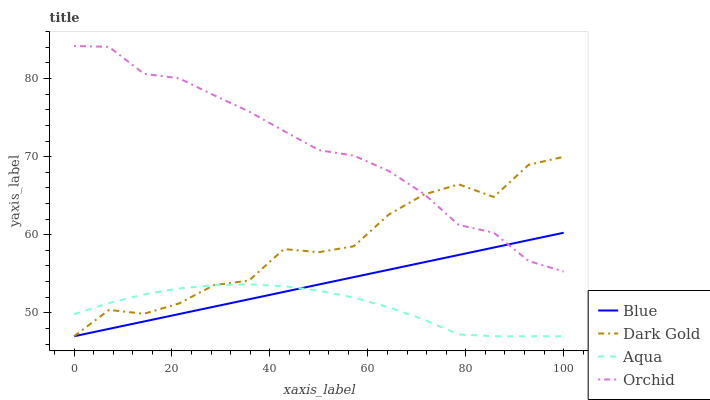Does Aqua have the minimum area under the curve?
Answer yes or no. Yes. Does Orchid have the maximum area under the curve?
Answer yes or no. Yes. Does Orchid have the minimum area under the curve?
Answer yes or no. No. Does Aqua have the maximum area under the curve?
Answer yes or no. No. Is Blue the smoothest?
Answer yes or no. Yes. Is Dark Gold the roughest?
Answer yes or no. Yes. Is Orchid the smoothest?
Answer yes or no. No. Is Orchid the roughest?
Answer yes or no. No. Does Blue have the lowest value?
Answer yes or no. Yes. Does Orchid have the lowest value?
Answer yes or no. No. Does Orchid have the highest value?
Answer yes or no. Yes. Does Aqua have the highest value?
Answer yes or no. No. Is Aqua less than Orchid?
Answer yes or no. Yes. Is Orchid greater than Aqua?
Answer yes or no. Yes. Does Aqua intersect Dark Gold?
Answer yes or no. Yes. Is Aqua less than Dark Gold?
Answer yes or no. No. Is Aqua greater than Dark Gold?
Answer yes or no. No. Does Aqua intersect Orchid?
Answer yes or no. No. 